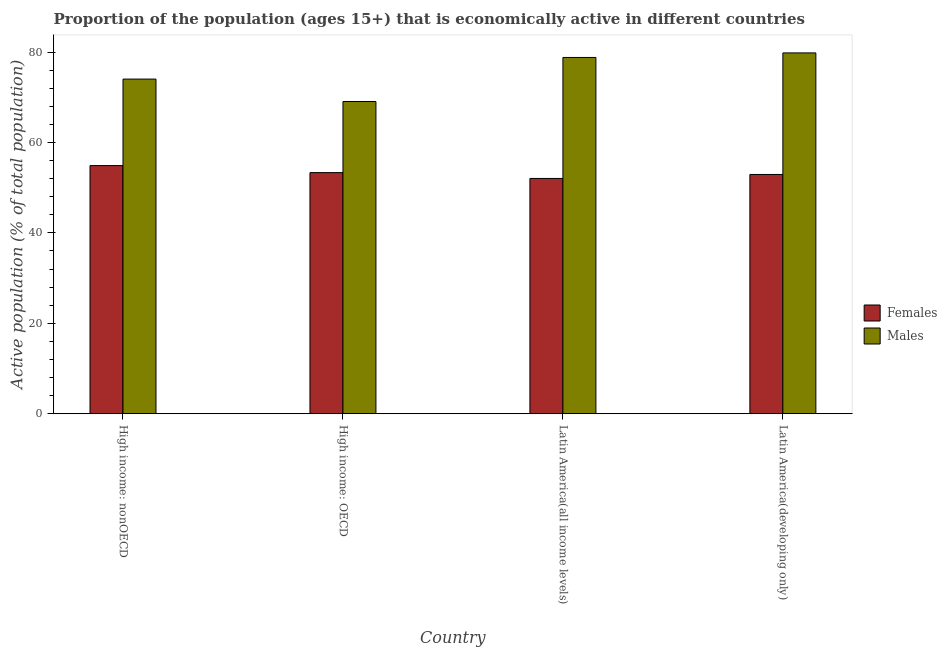How many different coloured bars are there?
Your answer should be compact. 2. How many groups of bars are there?
Your answer should be compact. 4. Are the number of bars per tick equal to the number of legend labels?
Your answer should be compact. Yes. What is the label of the 3rd group of bars from the left?
Offer a terse response. Latin America(all income levels). In how many cases, is the number of bars for a given country not equal to the number of legend labels?
Keep it short and to the point. 0. What is the percentage of economically active female population in Latin America(all income levels)?
Provide a succinct answer. 52.04. Across all countries, what is the maximum percentage of economically active female population?
Make the answer very short. 54.88. Across all countries, what is the minimum percentage of economically active female population?
Give a very brief answer. 52.04. In which country was the percentage of economically active female population maximum?
Your answer should be very brief. High income: nonOECD. In which country was the percentage of economically active female population minimum?
Your answer should be compact. Latin America(all income levels). What is the total percentage of economically active male population in the graph?
Give a very brief answer. 301.67. What is the difference between the percentage of economically active female population in High income: OECD and that in High income: nonOECD?
Offer a terse response. -1.56. What is the difference between the percentage of economically active female population in High income: OECD and the percentage of economically active male population in Latin America(developing only)?
Offer a very short reply. -26.48. What is the average percentage of economically active male population per country?
Provide a succinct answer. 75.42. What is the difference between the percentage of economically active male population and percentage of economically active female population in Latin America(all income levels)?
Your response must be concise. 26.76. In how many countries, is the percentage of economically active male population greater than 56 %?
Ensure brevity in your answer.  4. What is the ratio of the percentage of economically active female population in Latin America(all income levels) to that in Latin America(developing only)?
Offer a very short reply. 0.98. Is the percentage of economically active male population in High income: nonOECD less than that in Latin America(developing only)?
Give a very brief answer. Yes. Is the difference between the percentage of economically active male population in High income: OECD and High income: nonOECD greater than the difference between the percentage of economically active female population in High income: OECD and High income: nonOECD?
Your answer should be compact. No. What is the difference between the highest and the second highest percentage of economically active female population?
Make the answer very short. 1.56. What is the difference between the highest and the lowest percentage of economically active male population?
Offer a terse response. 10.74. What does the 1st bar from the left in High income: OECD represents?
Make the answer very short. Females. What does the 2nd bar from the right in Latin America(developing only) represents?
Make the answer very short. Females. How many bars are there?
Your answer should be very brief. 8. Are all the bars in the graph horizontal?
Make the answer very short. No. What is the difference between two consecutive major ticks on the Y-axis?
Ensure brevity in your answer.  20. Does the graph contain any zero values?
Keep it short and to the point. No. Where does the legend appear in the graph?
Provide a succinct answer. Center right. How many legend labels are there?
Make the answer very short. 2. What is the title of the graph?
Offer a terse response. Proportion of the population (ages 15+) that is economically active in different countries. Does "Central government" appear as one of the legend labels in the graph?
Provide a succinct answer. No. What is the label or title of the X-axis?
Give a very brief answer. Country. What is the label or title of the Y-axis?
Offer a terse response. Active population (% of total population). What is the Active population (% of total population) of Females in High income: nonOECD?
Offer a very short reply. 54.88. What is the Active population (% of total population) in Males in High income: nonOECD?
Provide a succinct answer. 74.02. What is the Active population (% of total population) in Females in High income: OECD?
Provide a succinct answer. 53.33. What is the Active population (% of total population) of Males in High income: OECD?
Ensure brevity in your answer.  69.06. What is the Active population (% of total population) in Females in Latin America(all income levels)?
Ensure brevity in your answer.  52.04. What is the Active population (% of total population) in Males in Latin America(all income levels)?
Your answer should be very brief. 78.8. What is the Active population (% of total population) of Females in Latin America(developing only)?
Offer a very short reply. 52.92. What is the Active population (% of total population) of Males in Latin America(developing only)?
Give a very brief answer. 79.8. Across all countries, what is the maximum Active population (% of total population) in Females?
Keep it short and to the point. 54.88. Across all countries, what is the maximum Active population (% of total population) in Males?
Ensure brevity in your answer.  79.8. Across all countries, what is the minimum Active population (% of total population) of Females?
Offer a very short reply. 52.04. Across all countries, what is the minimum Active population (% of total population) of Males?
Your answer should be compact. 69.06. What is the total Active population (% of total population) in Females in the graph?
Make the answer very short. 213.17. What is the total Active population (% of total population) of Males in the graph?
Ensure brevity in your answer.  301.67. What is the difference between the Active population (% of total population) of Females in High income: nonOECD and that in High income: OECD?
Your answer should be very brief. 1.56. What is the difference between the Active population (% of total population) in Males in High income: nonOECD and that in High income: OECD?
Provide a short and direct response. 4.96. What is the difference between the Active population (% of total population) in Females in High income: nonOECD and that in Latin America(all income levels)?
Your answer should be compact. 2.84. What is the difference between the Active population (% of total population) in Males in High income: nonOECD and that in Latin America(all income levels)?
Provide a short and direct response. -4.78. What is the difference between the Active population (% of total population) of Females in High income: nonOECD and that in Latin America(developing only)?
Give a very brief answer. 1.96. What is the difference between the Active population (% of total population) in Males in High income: nonOECD and that in Latin America(developing only)?
Your answer should be compact. -5.79. What is the difference between the Active population (% of total population) of Females in High income: OECD and that in Latin America(all income levels)?
Keep it short and to the point. 1.29. What is the difference between the Active population (% of total population) in Males in High income: OECD and that in Latin America(all income levels)?
Your answer should be compact. -9.74. What is the difference between the Active population (% of total population) in Females in High income: OECD and that in Latin America(developing only)?
Give a very brief answer. 0.41. What is the difference between the Active population (% of total population) of Males in High income: OECD and that in Latin America(developing only)?
Make the answer very short. -10.74. What is the difference between the Active population (% of total population) in Females in Latin America(all income levels) and that in Latin America(developing only)?
Offer a terse response. -0.88. What is the difference between the Active population (% of total population) in Males in Latin America(all income levels) and that in Latin America(developing only)?
Make the answer very short. -1.01. What is the difference between the Active population (% of total population) of Females in High income: nonOECD and the Active population (% of total population) of Males in High income: OECD?
Offer a very short reply. -14.18. What is the difference between the Active population (% of total population) of Females in High income: nonOECD and the Active population (% of total population) of Males in Latin America(all income levels)?
Provide a short and direct response. -23.91. What is the difference between the Active population (% of total population) of Females in High income: nonOECD and the Active population (% of total population) of Males in Latin America(developing only)?
Provide a short and direct response. -24.92. What is the difference between the Active population (% of total population) of Females in High income: OECD and the Active population (% of total population) of Males in Latin America(all income levels)?
Provide a short and direct response. -25.47. What is the difference between the Active population (% of total population) of Females in High income: OECD and the Active population (% of total population) of Males in Latin America(developing only)?
Provide a short and direct response. -26.48. What is the difference between the Active population (% of total population) of Females in Latin America(all income levels) and the Active population (% of total population) of Males in Latin America(developing only)?
Provide a short and direct response. -27.76. What is the average Active population (% of total population) of Females per country?
Offer a terse response. 53.29. What is the average Active population (% of total population) of Males per country?
Your answer should be very brief. 75.42. What is the difference between the Active population (% of total population) in Females and Active population (% of total population) in Males in High income: nonOECD?
Provide a succinct answer. -19.13. What is the difference between the Active population (% of total population) of Females and Active population (% of total population) of Males in High income: OECD?
Give a very brief answer. -15.73. What is the difference between the Active population (% of total population) in Females and Active population (% of total population) in Males in Latin America(all income levels)?
Make the answer very short. -26.76. What is the difference between the Active population (% of total population) of Females and Active population (% of total population) of Males in Latin America(developing only)?
Your answer should be compact. -26.88. What is the ratio of the Active population (% of total population) in Females in High income: nonOECD to that in High income: OECD?
Ensure brevity in your answer.  1.03. What is the ratio of the Active population (% of total population) in Males in High income: nonOECD to that in High income: OECD?
Offer a very short reply. 1.07. What is the ratio of the Active population (% of total population) of Females in High income: nonOECD to that in Latin America(all income levels)?
Provide a short and direct response. 1.05. What is the ratio of the Active population (% of total population) of Males in High income: nonOECD to that in Latin America(all income levels)?
Your answer should be very brief. 0.94. What is the ratio of the Active population (% of total population) of Females in High income: nonOECD to that in Latin America(developing only)?
Offer a very short reply. 1.04. What is the ratio of the Active population (% of total population) in Males in High income: nonOECD to that in Latin America(developing only)?
Offer a very short reply. 0.93. What is the ratio of the Active population (% of total population) of Females in High income: OECD to that in Latin America(all income levels)?
Give a very brief answer. 1.02. What is the ratio of the Active population (% of total population) of Males in High income: OECD to that in Latin America(all income levels)?
Provide a succinct answer. 0.88. What is the ratio of the Active population (% of total population) of Females in High income: OECD to that in Latin America(developing only)?
Your response must be concise. 1.01. What is the ratio of the Active population (% of total population) in Males in High income: OECD to that in Latin America(developing only)?
Give a very brief answer. 0.87. What is the ratio of the Active population (% of total population) of Females in Latin America(all income levels) to that in Latin America(developing only)?
Offer a terse response. 0.98. What is the ratio of the Active population (% of total population) of Males in Latin America(all income levels) to that in Latin America(developing only)?
Give a very brief answer. 0.99. What is the difference between the highest and the second highest Active population (% of total population) in Females?
Keep it short and to the point. 1.56. What is the difference between the highest and the lowest Active population (% of total population) of Females?
Your answer should be very brief. 2.84. What is the difference between the highest and the lowest Active population (% of total population) in Males?
Give a very brief answer. 10.74. 